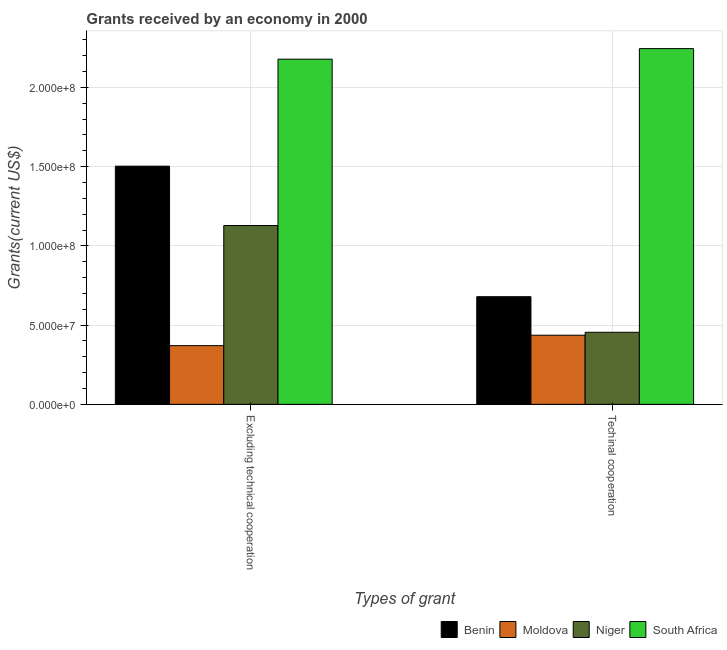Are the number of bars on each tick of the X-axis equal?
Your response must be concise. Yes. How many bars are there on the 2nd tick from the right?
Keep it short and to the point. 4. What is the label of the 1st group of bars from the left?
Provide a succinct answer. Excluding technical cooperation. What is the amount of grants received(excluding technical cooperation) in Moldova?
Offer a very short reply. 3.70e+07. Across all countries, what is the maximum amount of grants received(excluding technical cooperation)?
Make the answer very short. 2.18e+08. Across all countries, what is the minimum amount of grants received(excluding technical cooperation)?
Make the answer very short. 3.70e+07. In which country was the amount of grants received(including technical cooperation) maximum?
Provide a succinct answer. South Africa. In which country was the amount of grants received(excluding technical cooperation) minimum?
Your answer should be very brief. Moldova. What is the total amount of grants received(excluding technical cooperation) in the graph?
Provide a short and direct response. 5.18e+08. What is the difference between the amount of grants received(excluding technical cooperation) in South Africa and that in Benin?
Your answer should be very brief. 6.75e+07. What is the difference between the amount of grants received(including technical cooperation) in South Africa and the amount of grants received(excluding technical cooperation) in Benin?
Give a very brief answer. 7.42e+07. What is the average amount of grants received(including technical cooperation) per country?
Your answer should be very brief. 9.54e+07. What is the difference between the amount of grants received(excluding technical cooperation) and amount of grants received(including technical cooperation) in Benin?
Offer a very short reply. 8.24e+07. What is the ratio of the amount of grants received(including technical cooperation) in Niger to that in Benin?
Your answer should be very brief. 0.67. Is the amount of grants received(including technical cooperation) in Niger less than that in Moldova?
Your response must be concise. No. In how many countries, is the amount of grants received(excluding technical cooperation) greater than the average amount of grants received(excluding technical cooperation) taken over all countries?
Make the answer very short. 2. What does the 4th bar from the left in Techinal cooperation represents?
Keep it short and to the point. South Africa. What does the 4th bar from the right in Techinal cooperation represents?
Your answer should be very brief. Benin. How many bars are there?
Your answer should be compact. 8. Are all the bars in the graph horizontal?
Your response must be concise. No. What is the difference between two consecutive major ticks on the Y-axis?
Make the answer very short. 5.00e+07. Are the values on the major ticks of Y-axis written in scientific E-notation?
Provide a short and direct response. Yes. Does the graph contain grids?
Keep it short and to the point. Yes. What is the title of the graph?
Your answer should be compact. Grants received by an economy in 2000. What is the label or title of the X-axis?
Make the answer very short. Types of grant. What is the label or title of the Y-axis?
Offer a very short reply. Grants(current US$). What is the Grants(current US$) of Benin in Excluding technical cooperation?
Offer a terse response. 1.50e+08. What is the Grants(current US$) in Moldova in Excluding technical cooperation?
Make the answer very short. 3.70e+07. What is the Grants(current US$) of Niger in Excluding technical cooperation?
Provide a succinct answer. 1.13e+08. What is the Grants(current US$) of South Africa in Excluding technical cooperation?
Offer a very short reply. 2.18e+08. What is the Grants(current US$) of Benin in Techinal cooperation?
Your answer should be very brief. 6.79e+07. What is the Grants(current US$) of Moldova in Techinal cooperation?
Offer a terse response. 4.36e+07. What is the Grants(current US$) in Niger in Techinal cooperation?
Give a very brief answer. 4.55e+07. What is the Grants(current US$) in South Africa in Techinal cooperation?
Your answer should be very brief. 2.24e+08. Across all Types of grant, what is the maximum Grants(current US$) in Benin?
Ensure brevity in your answer.  1.50e+08. Across all Types of grant, what is the maximum Grants(current US$) in Moldova?
Your answer should be very brief. 4.36e+07. Across all Types of grant, what is the maximum Grants(current US$) in Niger?
Your answer should be very brief. 1.13e+08. Across all Types of grant, what is the maximum Grants(current US$) of South Africa?
Offer a terse response. 2.24e+08. Across all Types of grant, what is the minimum Grants(current US$) of Benin?
Make the answer very short. 6.79e+07. Across all Types of grant, what is the minimum Grants(current US$) in Moldova?
Ensure brevity in your answer.  3.70e+07. Across all Types of grant, what is the minimum Grants(current US$) of Niger?
Your response must be concise. 4.55e+07. Across all Types of grant, what is the minimum Grants(current US$) of South Africa?
Keep it short and to the point. 2.18e+08. What is the total Grants(current US$) in Benin in the graph?
Your answer should be compact. 2.18e+08. What is the total Grants(current US$) of Moldova in the graph?
Your answer should be very brief. 8.07e+07. What is the total Grants(current US$) of Niger in the graph?
Give a very brief answer. 1.58e+08. What is the total Grants(current US$) of South Africa in the graph?
Ensure brevity in your answer.  4.42e+08. What is the difference between the Grants(current US$) in Benin in Excluding technical cooperation and that in Techinal cooperation?
Your answer should be very brief. 8.24e+07. What is the difference between the Grants(current US$) of Moldova in Excluding technical cooperation and that in Techinal cooperation?
Your answer should be very brief. -6.58e+06. What is the difference between the Grants(current US$) in Niger in Excluding technical cooperation and that in Techinal cooperation?
Offer a terse response. 6.74e+07. What is the difference between the Grants(current US$) of South Africa in Excluding technical cooperation and that in Techinal cooperation?
Keep it short and to the point. -6.66e+06. What is the difference between the Grants(current US$) of Benin in Excluding technical cooperation and the Grants(current US$) of Moldova in Techinal cooperation?
Your answer should be compact. 1.07e+08. What is the difference between the Grants(current US$) of Benin in Excluding technical cooperation and the Grants(current US$) of Niger in Techinal cooperation?
Ensure brevity in your answer.  1.05e+08. What is the difference between the Grants(current US$) of Benin in Excluding technical cooperation and the Grants(current US$) of South Africa in Techinal cooperation?
Give a very brief answer. -7.42e+07. What is the difference between the Grants(current US$) of Moldova in Excluding technical cooperation and the Grants(current US$) of Niger in Techinal cooperation?
Make the answer very short. -8.43e+06. What is the difference between the Grants(current US$) in Moldova in Excluding technical cooperation and the Grants(current US$) in South Africa in Techinal cooperation?
Your answer should be compact. -1.87e+08. What is the difference between the Grants(current US$) of Niger in Excluding technical cooperation and the Grants(current US$) of South Africa in Techinal cooperation?
Keep it short and to the point. -1.12e+08. What is the average Grants(current US$) in Benin per Types of grant?
Offer a very short reply. 1.09e+08. What is the average Grants(current US$) of Moldova per Types of grant?
Provide a short and direct response. 4.03e+07. What is the average Grants(current US$) in Niger per Types of grant?
Your response must be concise. 7.92e+07. What is the average Grants(current US$) of South Africa per Types of grant?
Your answer should be compact. 2.21e+08. What is the difference between the Grants(current US$) in Benin and Grants(current US$) in Moldova in Excluding technical cooperation?
Ensure brevity in your answer.  1.13e+08. What is the difference between the Grants(current US$) in Benin and Grants(current US$) in Niger in Excluding technical cooperation?
Ensure brevity in your answer.  3.74e+07. What is the difference between the Grants(current US$) of Benin and Grants(current US$) of South Africa in Excluding technical cooperation?
Your answer should be compact. -6.75e+07. What is the difference between the Grants(current US$) of Moldova and Grants(current US$) of Niger in Excluding technical cooperation?
Your answer should be very brief. -7.58e+07. What is the difference between the Grants(current US$) of Moldova and Grants(current US$) of South Africa in Excluding technical cooperation?
Your answer should be very brief. -1.81e+08. What is the difference between the Grants(current US$) in Niger and Grants(current US$) in South Africa in Excluding technical cooperation?
Provide a short and direct response. -1.05e+08. What is the difference between the Grants(current US$) of Benin and Grants(current US$) of Moldova in Techinal cooperation?
Provide a succinct answer. 2.43e+07. What is the difference between the Grants(current US$) in Benin and Grants(current US$) in Niger in Techinal cooperation?
Make the answer very short. 2.25e+07. What is the difference between the Grants(current US$) of Benin and Grants(current US$) of South Africa in Techinal cooperation?
Your answer should be compact. -1.57e+08. What is the difference between the Grants(current US$) of Moldova and Grants(current US$) of Niger in Techinal cooperation?
Your answer should be very brief. -1.85e+06. What is the difference between the Grants(current US$) in Moldova and Grants(current US$) in South Africa in Techinal cooperation?
Keep it short and to the point. -1.81e+08. What is the difference between the Grants(current US$) of Niger and Grants(current US$) of South Africa in Techinal cooperation?
Your answer should be very brief. -1.79e+08. What is the ratio of the Grants(current US$) in Benin in Excluding technical cooperation to that in Techinal cooperation?
Your response must be concise. 2.21. What is the ratio of the Grants(current US$) in Moldova in Excluding technical cooperation to that in Techinal cooperation?
Make the answer very short. 0.85. What is the ratio of the Grants(current US$) in Niger in Excluding technical cooperation to that in Techinal cooperation?
Offer a very short reply. 2.48. What is the ratio of the Grants(current US$) of South Africa in Excluding technical cooperation to that in Techinal cooperation?
Ensure brevity in your answer.  0.97. What is the difference between the highest and the second highest Grants(current US$) of Benin?
Ensure brevity in your answer.  8.24e+07. What is the difference between the highest and the second highest Grants(current US$) in Moldova?
Make the answer very short. 6.58e+06. What is the difference between the highest and the second highest Grants(current US$) in Niger?
Keep it short and to the point. 6.74e+07. What is the difference between the highest and the second highest Grants(current US$) in South Africa?
Your answer should be compact. 6.66e+06. What is the difference between the highest and the lowest Grants(current US$) in Benin?
Keep it short and to the point. 8.24e+07. What is the difference between the highest and the lowest Grants(current US$) of Moldova?
Your answer should be very brief. 6.58e+06. What is the difference between the highest and the lowest Grants(current US$) in Niger?
Your answer should be very brief. 6.74e+07. What is the difference between the highest and the lowest Grants(current US$) of South Africa?
Offer a very short reply. 6.66e+06. 